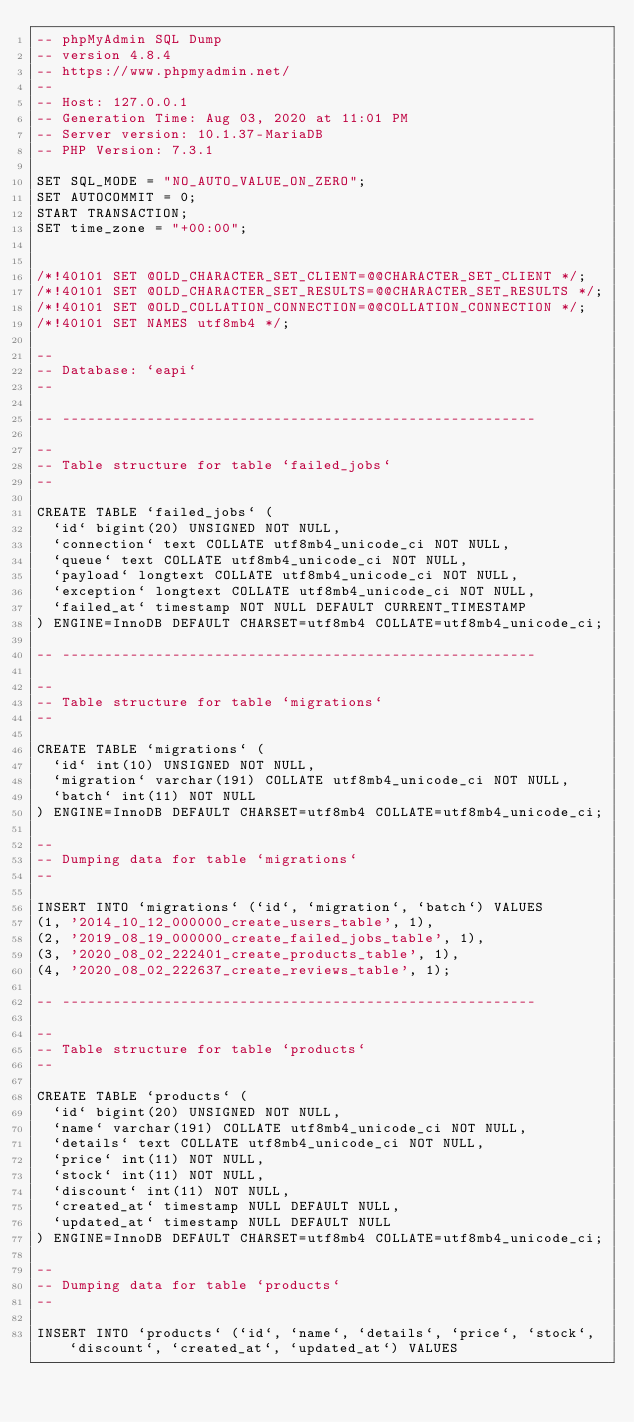<code> <loc_0><loc_0><loc_500><loc_500><_SQL_>-- phpMyAdmin SQL Dump
-- version 4.8.4
-- https://www.phpmyadmin.net/
--
-- Host: 127.0.0.1
-- Generation Time: Aug 03, 2020 at 11:01 PM
-- Server version: 10.1.37-MariaDB
-- PHP Version: 7.3.1

SET SQL_MODE = "NO_AUTO_VALUE_ON_ZERO";
SET AUTOCOMMIT = 0;
START TRANSACTION;
SET time_zone = "+00:00";


/*!40101 SET @OLD_CHARACTER_SET_CLIENT=@@CHARACTER_SET_CLIENT */;
/*!40101 SET @OLD_CHARACTER_SET_RESULTS=@@CHARACTER_SET_RESULTS */;
/*!40101 SET @OLD_COLLATION_CONNECTION=@@COLLATION_CONNECTION */;
/*!40101 SET NAMES utf8mb4 */;

--
-- Database: `eapi`
--

-- --------------------------------------------------------

--
-- Table structure for table `failed_jobs`
--

CREATE TABLE `failed_jobs` (
  `id` bigint(20) UNSIGNED NOT NULL,
  `connection` text COLLATE utf8mb4_unicode_ci NOT NULL,
  `queue` text COLLATE utf8mb4_unicode_ci NOT NULL,
  `payload` longtext COLLATE utf8mb4_unicode_ci NOT NULL,
  `exception` longtext COLLATE utf8mb4_unicode_ci NOT NULL,
  `failed_at` timestamp NOT NULL DEFAULT CURRENT_TIMESTAMP
) ENGINE=InnoDB DEFAULT CHARSET=utf8mb4 COLLATE=utf8mb4_unicode_ci;

-- --------------------------------------------------------

--
-- Table structure for table `migrations`
--

CREATE TABLE `migrations` (
  `id` int(10) UNSIGNED NOT NULL,
  `migration` varchar(191) COLLATE utf8mb4_unicode_ci NOT NULL,
  `batch` int(11) NOT NULL
) ENGINE=InnoDB DEFAULT CHARSET=utf8mb4 COLLATE=utf8mb4_unicode_ci;

--
-- Dumping data for table `migrations`
--

INSERT INTO `migrations` (`id`, `migration`, `batch`) VALUES
(1, '2014_10_12_000000_create_users_table', 1),
(2, '2019_08_19_000000_create_failed_jobs_table', 1),
(3, '2020_08_02_222401_create_products_table', 1),
(4, '2020_08_02_222637_create_reviews_table', 1);

-- --------------------------------------------------------

--
-- Table structure for table `products`
--

CREATE TABLE `products` (
  `id` bigint(20) UNSIGNED NOT NULL,
  `name` varchar(191) COLLATE utf8mb4_unicode_ci NOT NULL,
  `details` text COLLATE utf8mb4_unicode_ci NOT NULL,
  `price` int(11) NOT NULL,
  `stock` int(11) NOT NULL,
  `discount` int(11) NOT NULL,
  `created_at` timestamp NULL DEFAULT NULL,
  `updated_at` timestamp NULL DEFAULT NULL
) ENGINE=InnoDB DEFAULT CHARSET=utf8mb4 COLLATE=utf8mb4_unicode_ci;

--
-- Dumping data for table `products`
--

INSERT INTO `products` (`id`, `name`, `details`, `price`, `stock`, `discount`, `created_at`, `updated_at`) VALUES</code> 